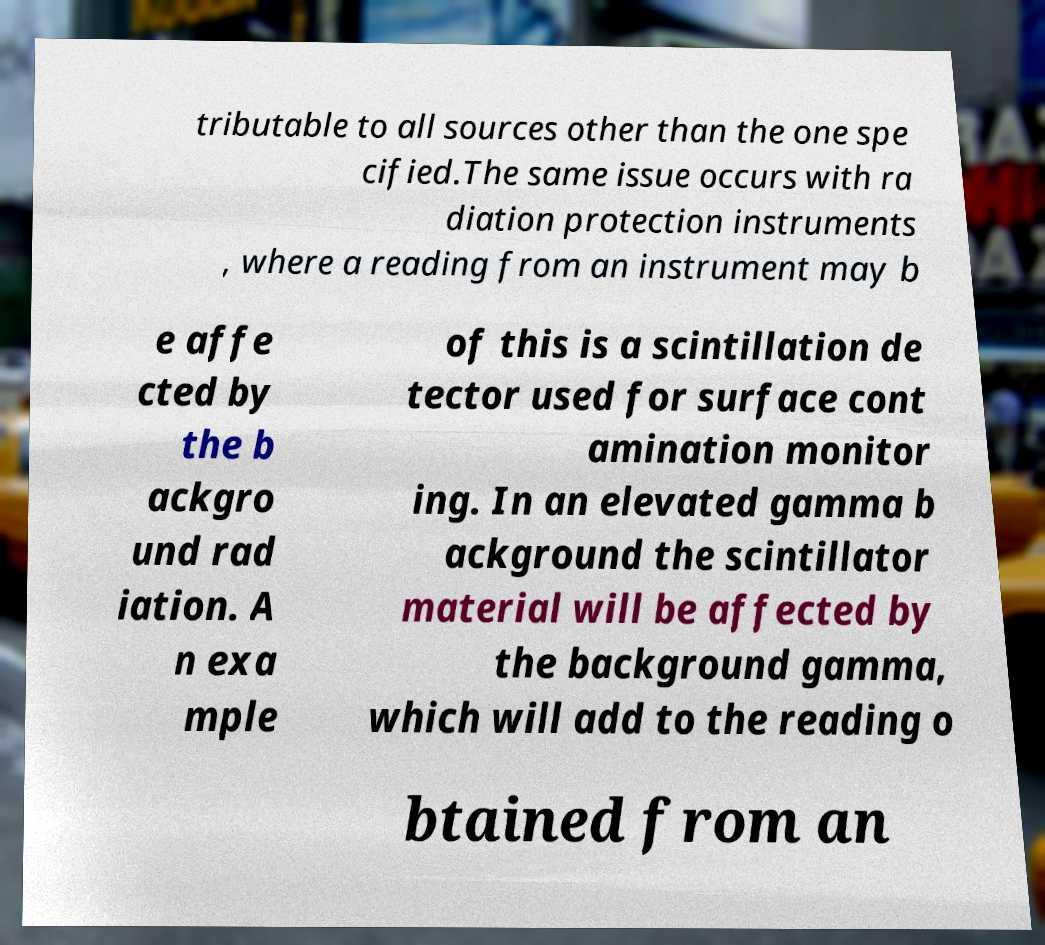I need the written content from this picture converted into text. Can you do that? tributable to all sources other than the one spe cified.The same issue occurs with ra diation protection instruments , where a reading from an instrument may b e affe cted by the b ackgro und rad iation. A n exa mple of this is a scintillation de tector used for surface cont amination monitor ing. In an elevated gamma b ackground the scintillator material will be affected by the background gamma, which will add to the reading o btained from an 